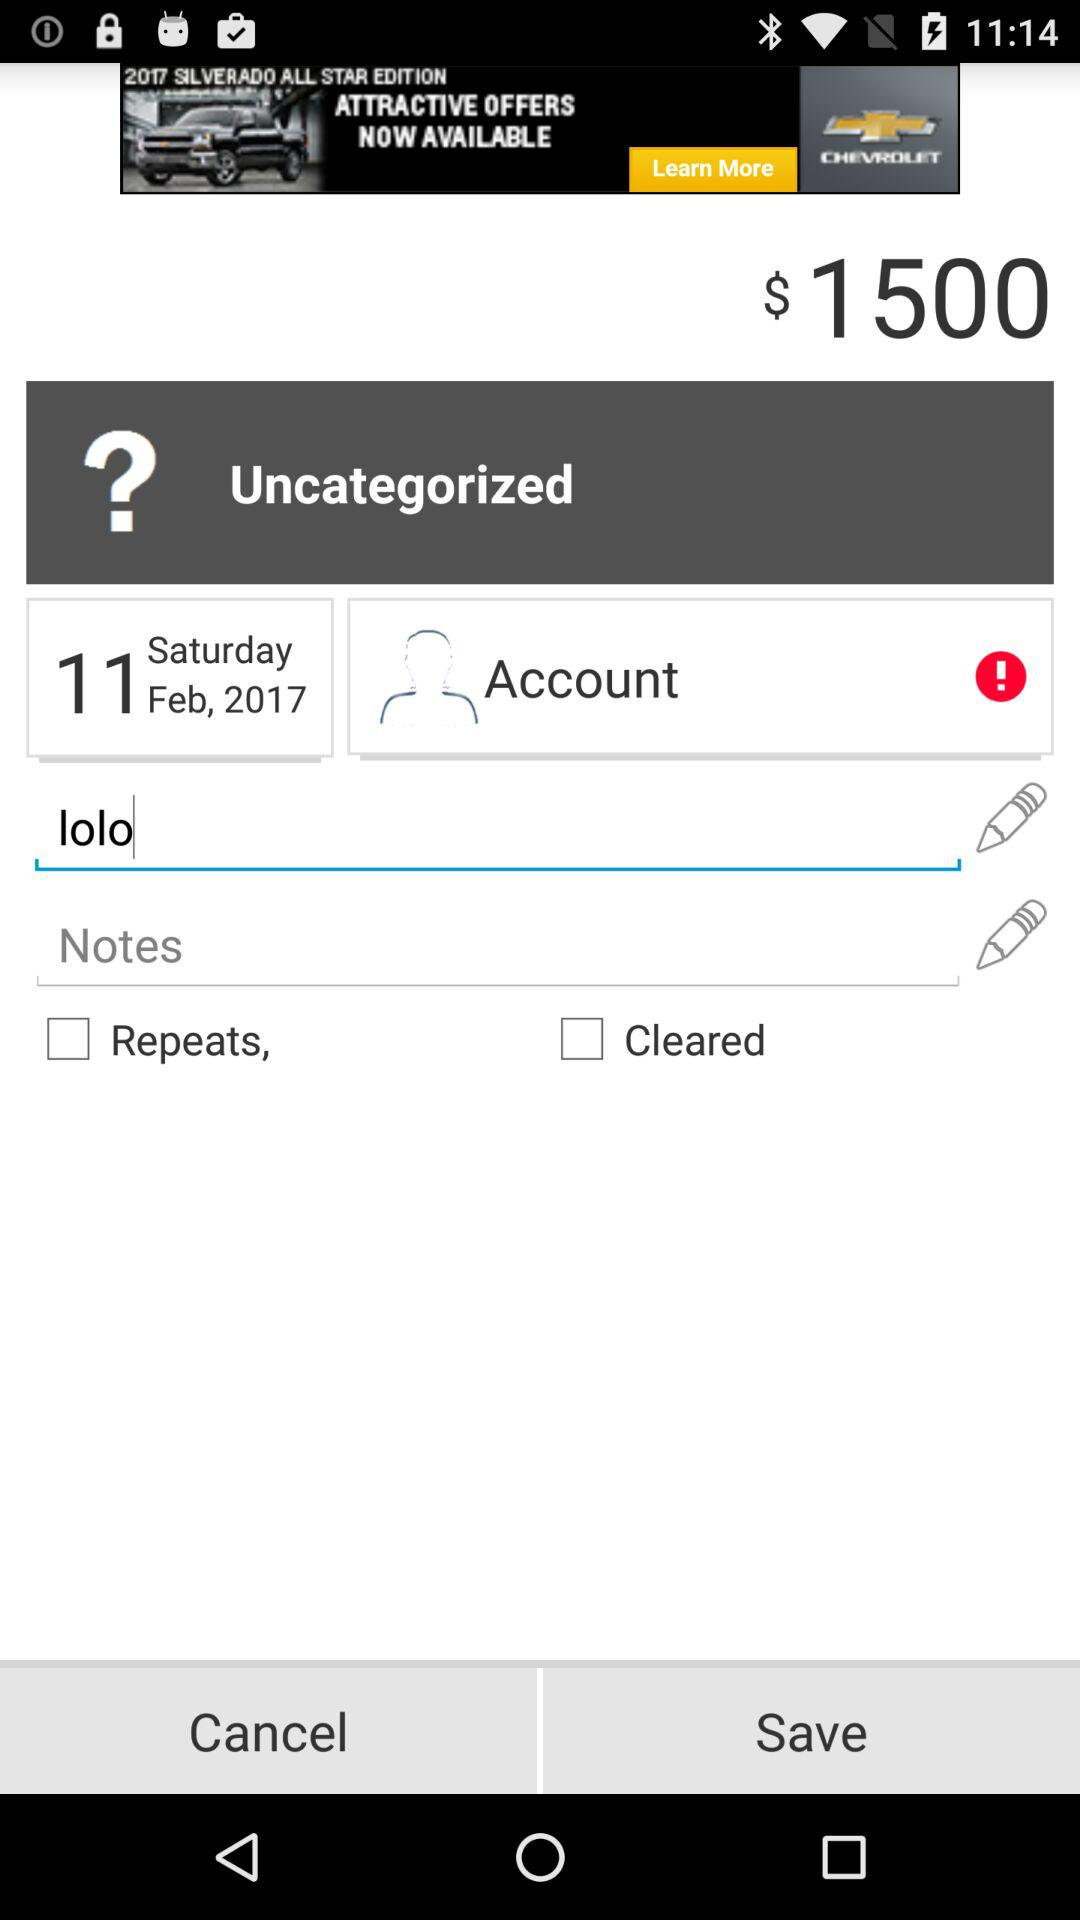What day was February 11, 2017? The day was Saturday. 